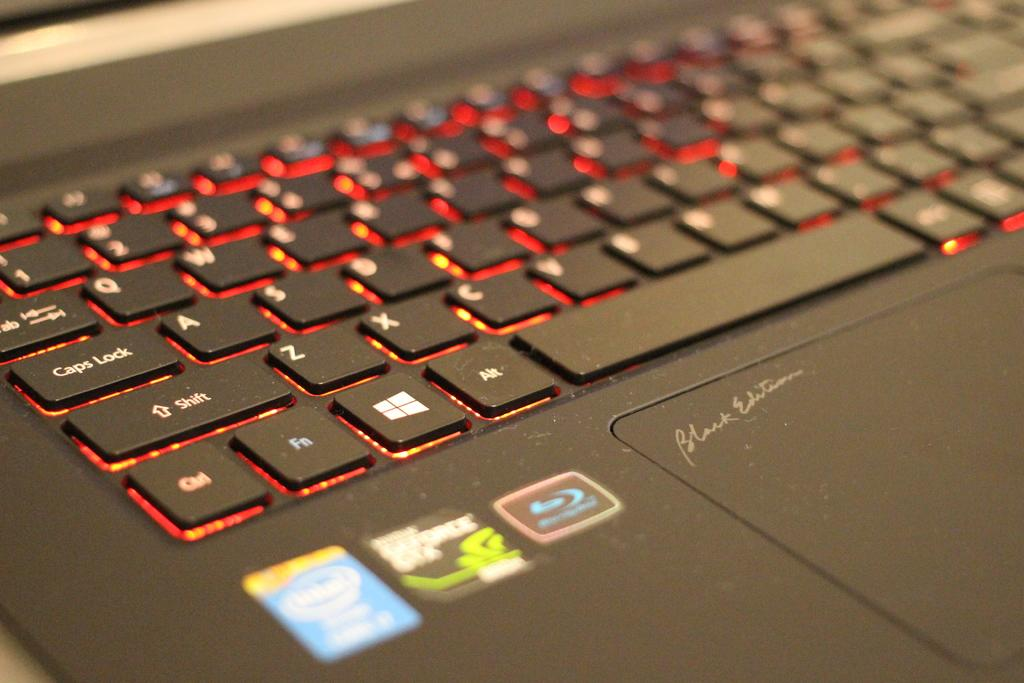What type of device is featured in the image? There is a keyboard in the image, which belongs to a laptop. What can be used to type on the laptop? The keyboard on the laptop can be used to type. Are there any identifiable logos on the laptop? Yes, there are logos visible on the laptop. What is the color of the laptop in the image? The laptop is black in color. Can you see any rabbits or mice interacting with the laptop in the image? No, there are no rabbits or mice present in the image. What type of discovery was made using the laptop in the image? There is no information about any discoveries made using the laptop in the image. 